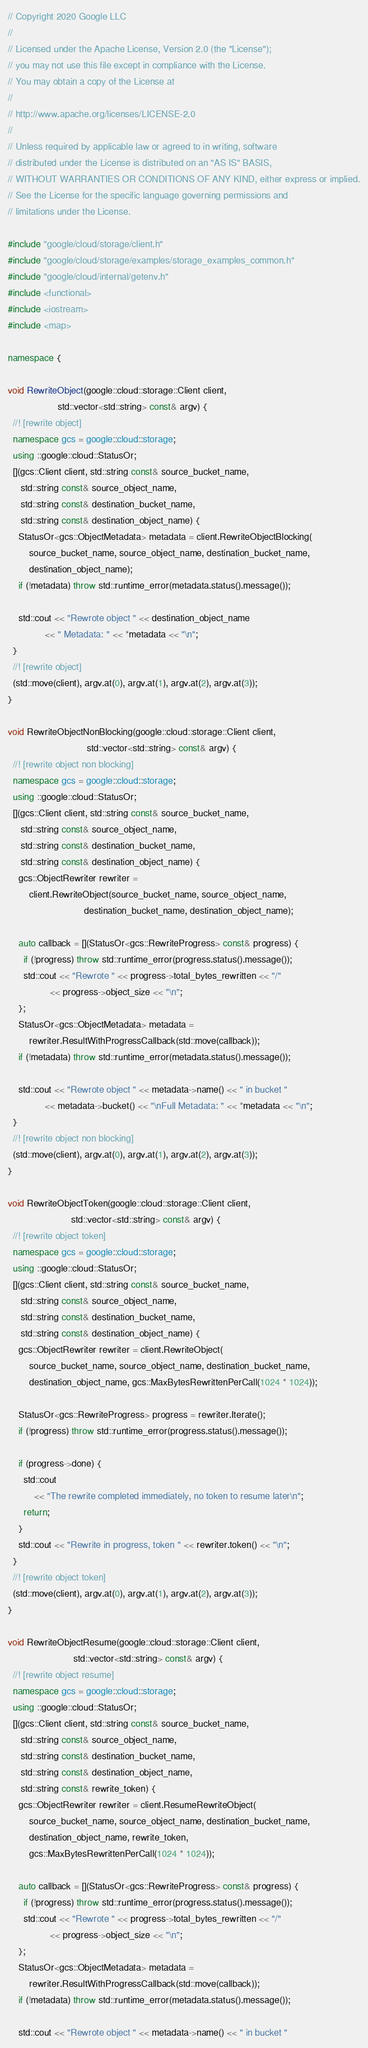Convert code to text. <code><loc_0><loc_0><loc_500><loc_500><_C++_>// Copyright 2020 Google LLC
//
// Licensed under the Apache License, Version 2.0 (the "License");
// you may not use this file except in compliance with the License.
// You may obtain a copy of the License at
//
// http://www.apache.org/licenses/LICENSE-2.0
//
// Unless required by applicable law or agreed to in writing, software
// distributed under the License is distributed on an "AS IS" BASIS,
// WITHOUT WARRANTIES OR CONDITIONS OF ANY KIND, either express or implied.
// See the License for the specific language governing permissions and
// limitations under the License.

#include "google/cloud/storage/client.h"
#include "google/cloud/storage/examples/storage_examples_common.h"
#include "google/cloud/internal/getenv.h"
#include <functional>
#include <iostream>
#include <map>

namespace {

void RewriteObject(google::cloud::storage::Client client,
                   std::vector<std::string> const& argv) {
  //! [rewrite object]
  namespace gcs = google::cloud::storage;
  using ::google::cloud::StatusOr;
  [](gcs::Client client, std::string const& source_bucket_name,
     std::string const& source_object_name,
     std::string const& destination_bucket_name,
     std::string const& destination_object_name) {
    StatusOr<gcs::ObjectMetadata> metadata = client.RewriteObjectBlocking(
        source_bucket_name, source_object_name, destination_bucket_name,
        destination_object_name);
    if (!metadata) throw std::runtime_error(metadata.status().message());

    std::cout << "Rewrote object " << destination_object_name
              << " Metadata: " << *metadata << "\n";
  }
  //! [rewrite object]
  (std::move(client), argv.at(0), argv.at(1), argv.at(2), argv.at(3));
}

void RewriteObjectNonBlocking(google::cloud::storage::Client client,
                              std::vector<std::string> const& argv) {
  //! [rewrite object non blocking]
  namespace gcs = google::cloud::storage;
  using ::google::cloud::StatusOr;
  [](gcs::Client client, std::string const& source_bucket_name,
     std::string const& source_object_name,
     std::string const& destination_bucket_name,
     std::string const& destination_object_name) {
    gcs::ObjectRewriter rewriter =
        client.RewriteObject(source_bucket_name, source_object_name,
                             destination_bucket_name, destination_object_name);

    auto callback = [](StatusOr<gcs::RewriteProgress> const& progress) {
      if (!progress) throw std::runtime_error(progress.status().message());
      std::cout << "Rewrote " << progress->total_bytes_rewritten << "/"
                << progress->object_size << "\n";
    };
    StatusOr<gcs::ObjectMetadata> metadata =
        rewriter.ResultWithProgressCallback(std::move(callback));
    if (!metadata) throw std::runtime_error(metadata.status().message());

    std::cout << "Rewrote object " << metadata->name() << " in bucket "
              << metadata->bucket() << "\nFull Metadata: " << *metadata << "\n";
  }
  //! [rewrite object non blocking]
  (std::move(client), argv.at(0), argv.at(1), argv.at(2), argv.at(3));
}

void RewriteObjectToken(google::cloud::storage::Client client,
                        std::vector<std::string> const& argv) {
  //! [rewrite object token]
  namespace gcs = google::cloud::storage;
  using ::google::cloud::StatusOr;
  [](gcs::Client client, std::string const& source_bucket_name,
     std::string const& source_object_name,
     std::string const& destination_bucket_name,
     std::string const& destination_object_name) {
    gcs::ObjectRewriter rewriter = client.RewriteObject(
        source_bucket_name, source_object_name, destination_bucket_name,
        destination_object_name, gcs::MaxBytesRewrittenPerCall(1024 * 1024));

    StatusOr<gcs::RewriteProgress> progress = rewriter.Iterate();
    if (!progress) throw std::runtime_error(progress.status().message());

    if (progress->done) {
      std::cout
          << "The rewrite completed immediately, no token to resume later\n";
      return;
    }
    std::cout << "Rewrite in progress, token " << rewriter.token() << "\n";
  }
  //! [rewrite object token]
  (std::move(client), argv.at(0), argv.at(1), argv.at(2), argv.at(3));
}

void RewriteObjectResume(google::cloud::storage::Client client,
                         std::vector<std::string> const& argv) {
  //! [rewrite object resume]
  namespace gcs = google::cloud::storage;
  using ::google::cloud::StatusOr;
  [](gcs::Client client, std::string const& source_bucket_name,
     std::string const& source_object_name,
     std::string const& destination_bucket_name,
     std::string const& destination_object_name,
     std::string const& rewrite_token) {
    gcs::ObjectRewriter rewriter = client.ResumeRewriteObject(
        source_bucket_name, source_object_name, destination_bucket_name,
        destination_object_name, rewrite_token,
        gcs::MaxBytesRewrittenPerCall(1024 * 1024));

    auto callback = [](StatusOr<gcs::RewriteProgress> const& progress) {
      if (!progress) throw std::runtime_error(progress.status().message());
      std::cout << "Rewrote " << progress->total_bytes_rewritten << "/"
                << progress->object_size << "\n";
    };
    StatusOr<gcs::ObjectMetadata> metadata =
        rewriter.ResultWithProgressCallback(std::move(callback));
    if (!metadata) throw std::runtime_error(metadata.status().message());

    std::cout << "Rewrote object " << metadata->name() << " in bucket "</code> 